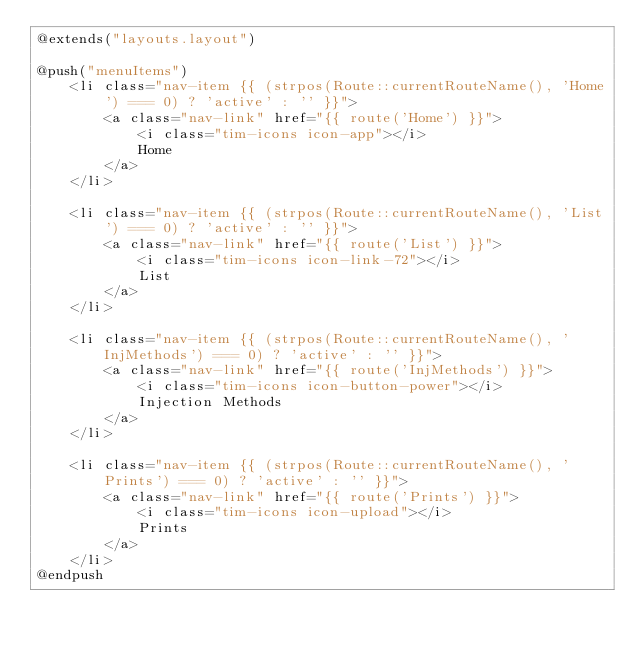Convert code to text. <code><loc_0><loc_0><loc_500><loc_500><_PHP_>@extends("layouts.layout")

@push("menuItems")
    <li class="nav-item {{ (strpos(Route::currentRouteName(), 'Home') === 0) ? 'active' : '' }}">
        <a class="nav-link" href="{{ route('Home') }}">
            <i class="tim-icons icon-app"></i>
            Home
        </a>
    </li>

    <li class="nav-item {{ (strpos(Route::currentRouteName(), 'List') === 0) ? 'active' : '' }}">
        <a class="nav-link" href="{{ route('List') }}">
            <i class="tim-icons icon-link-72"></i>
            List
        </a>
    </li>

    <li class="nav-item {{ (strpos(Route::currentRouteName(), 'InjMethods') === 0) ? 'active' : '' }}">
        <a class="nav-link" href="{{ route('InjMethods') }}">
            <i class="tim-icons icon-button-power"></i>
            Injection Methods
        </a>
    </li>

    <li class="nav-item {{ (strpos(Route::currentRouteName(), 'Prints') === 0) ? 'active' : '' }}">
        <a class="nav-link" href="{{ route('Prints') }}">
            <i class="tim-icons icon-upload"></i>
            Prints
        </a>
    </li>
@endpush
</code> 